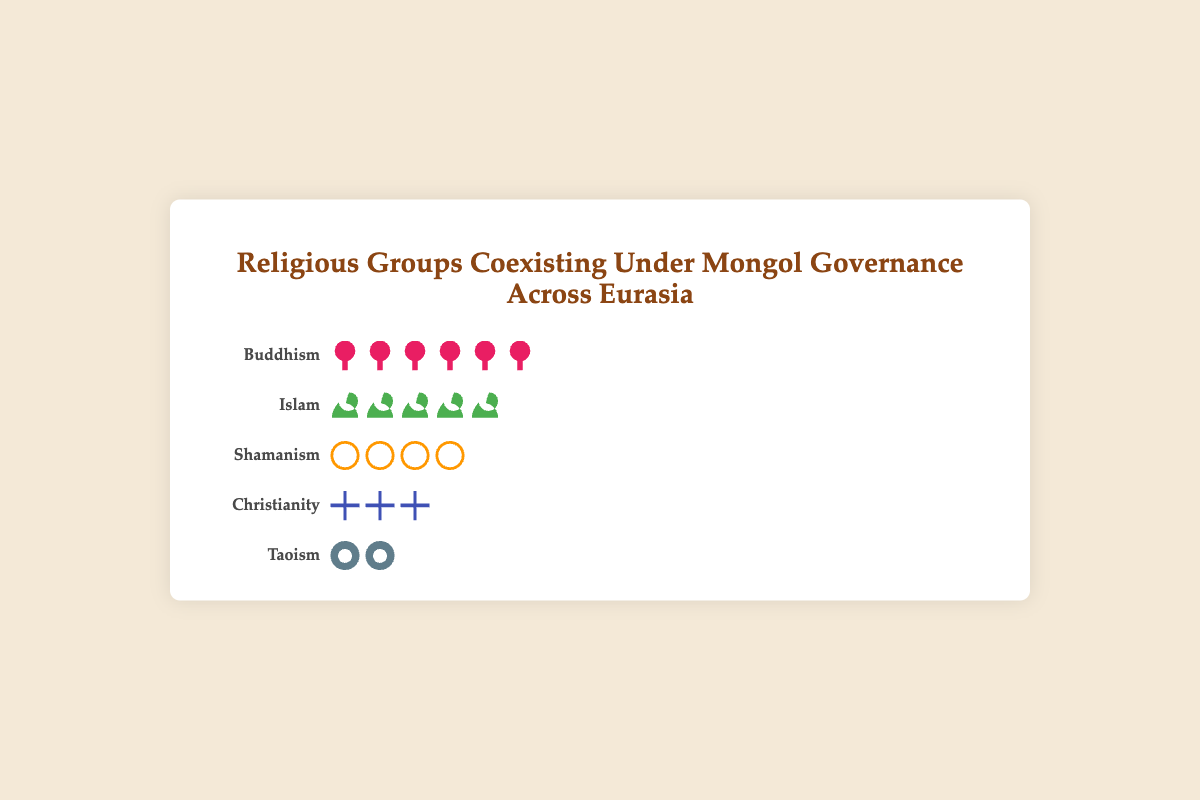What is the proportion of the Buddhism group? The proportion of the Buddhism group is indicated by 6 lotus icons. With each icon representing 5%, the total proportion for Buddhism is calculated as 6 * 5%.
Answer: 30% Which religious group has the second-largest proportion? Among the religious groups, the second-largest proportion is represented by 5 crescent icons. Each representing 5%, the group with 25% is Islam.
Answer: Islam How many icons are used to represent Taoism? There are 2 yin-yang icons displayed for Taoism. Each icon represents 5%, making a total proportion of 10%.
Answer: 2 What is the combined proportion of Shamanism and Christianity groups? Shamanism is represented by 4 drum icons (4 * 5% = 20%) and Christianity by 3 cross icons (3 * 5% = 15%). Adding these proportions gives 20% + 15%.
Answer: 35% Which group has the smallest proportion, and what is it? The group with the smallest proportion is Taoism, represented by 2 yin-yang icons, each representing 5%, resulting in a total of 10%.
Answer: Taoism, 10% What is the proportion difference between Buddhism and Christianity? Buddhism has 6 icons (30%) and Christianity has 3 icons (15%). The difference is calculated as 30% - 15%.
Answer: 15% Arrange the religious groups in descending order of their proportions. Based on the number of icons: Buddhism (30%), Islam (25%), Shamanism (20%), Christianity (15%), Taoism (10%).
Answer: Buddhism, Islam, Shamanism, Christianity, Taoism How many icons are there in total representing all religious groups? Each group's icons are summed up: Buddhism (6) + Islam (5) + Shamanism (4) + Christianity (3) + Taoism (2). The total is 6 + 5 + 4 + 3 + 2.
Answer: 20 